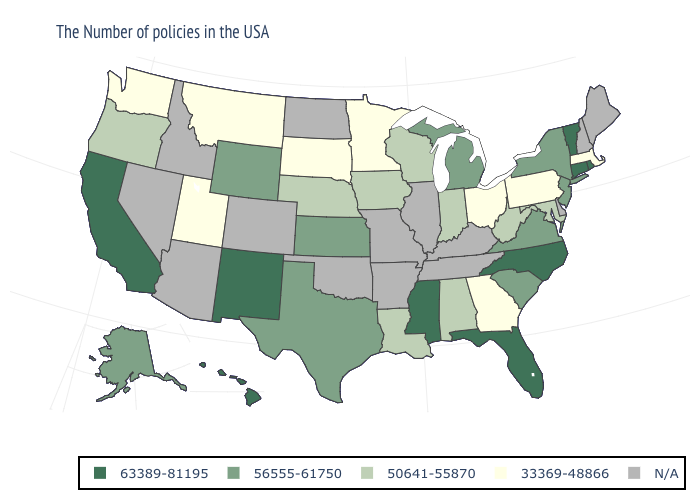What is the value of New Jersey?
Be succinct. 56555-61750. Which states have the lowest value in the USA?
Keep it brief. Massachusetts, Pennsylvania, Ohio, Georgia, Minnesota, South Dakota, Utah, Montana, Washington. What is the value of Oregon?
Short answer required. 50641-55870. Which states have the lowest value in the USA?
Keep it brief. Massachusetts, Pennsylvania, Ohio, Georgia, Minnesota, South Dakota, Utah, Montana, Washington. Which states have the lowest value in the USA?
Quick response, please. Massachusetts, Pennsylvania, Ohio, Georgia, Minnesota, South Dakota, Utah, Montana, Washington. Among the states that border New Jersey , does New York have the highest value?
Answer briefly. Yes. What is the highest value in the Northeast ?
Quick response, please. 63389-81195. Name the states that have a value in the range 63389-81195?
Write a very short answer. Rhode Island, Vermont, Connecticut, North Carolina, Florida, Mississippi, New Mexico, California, Hawaii. Among the states that border Tennessee , does Georgia have the lowest value?
Quick response, please. Yes. What is the value of Delaware?
Quick response, please. N/A. Name the states that have a value in the range 50641-55870?
Quick response, please. Maryland, West Virginia, Indiana, Alabama, Wisconsin, Louisiana, Iowa, Nebraska, Oregon. Among the states that border New Mexico , which have the lowest value?
Give a very brief answer. Utah. 